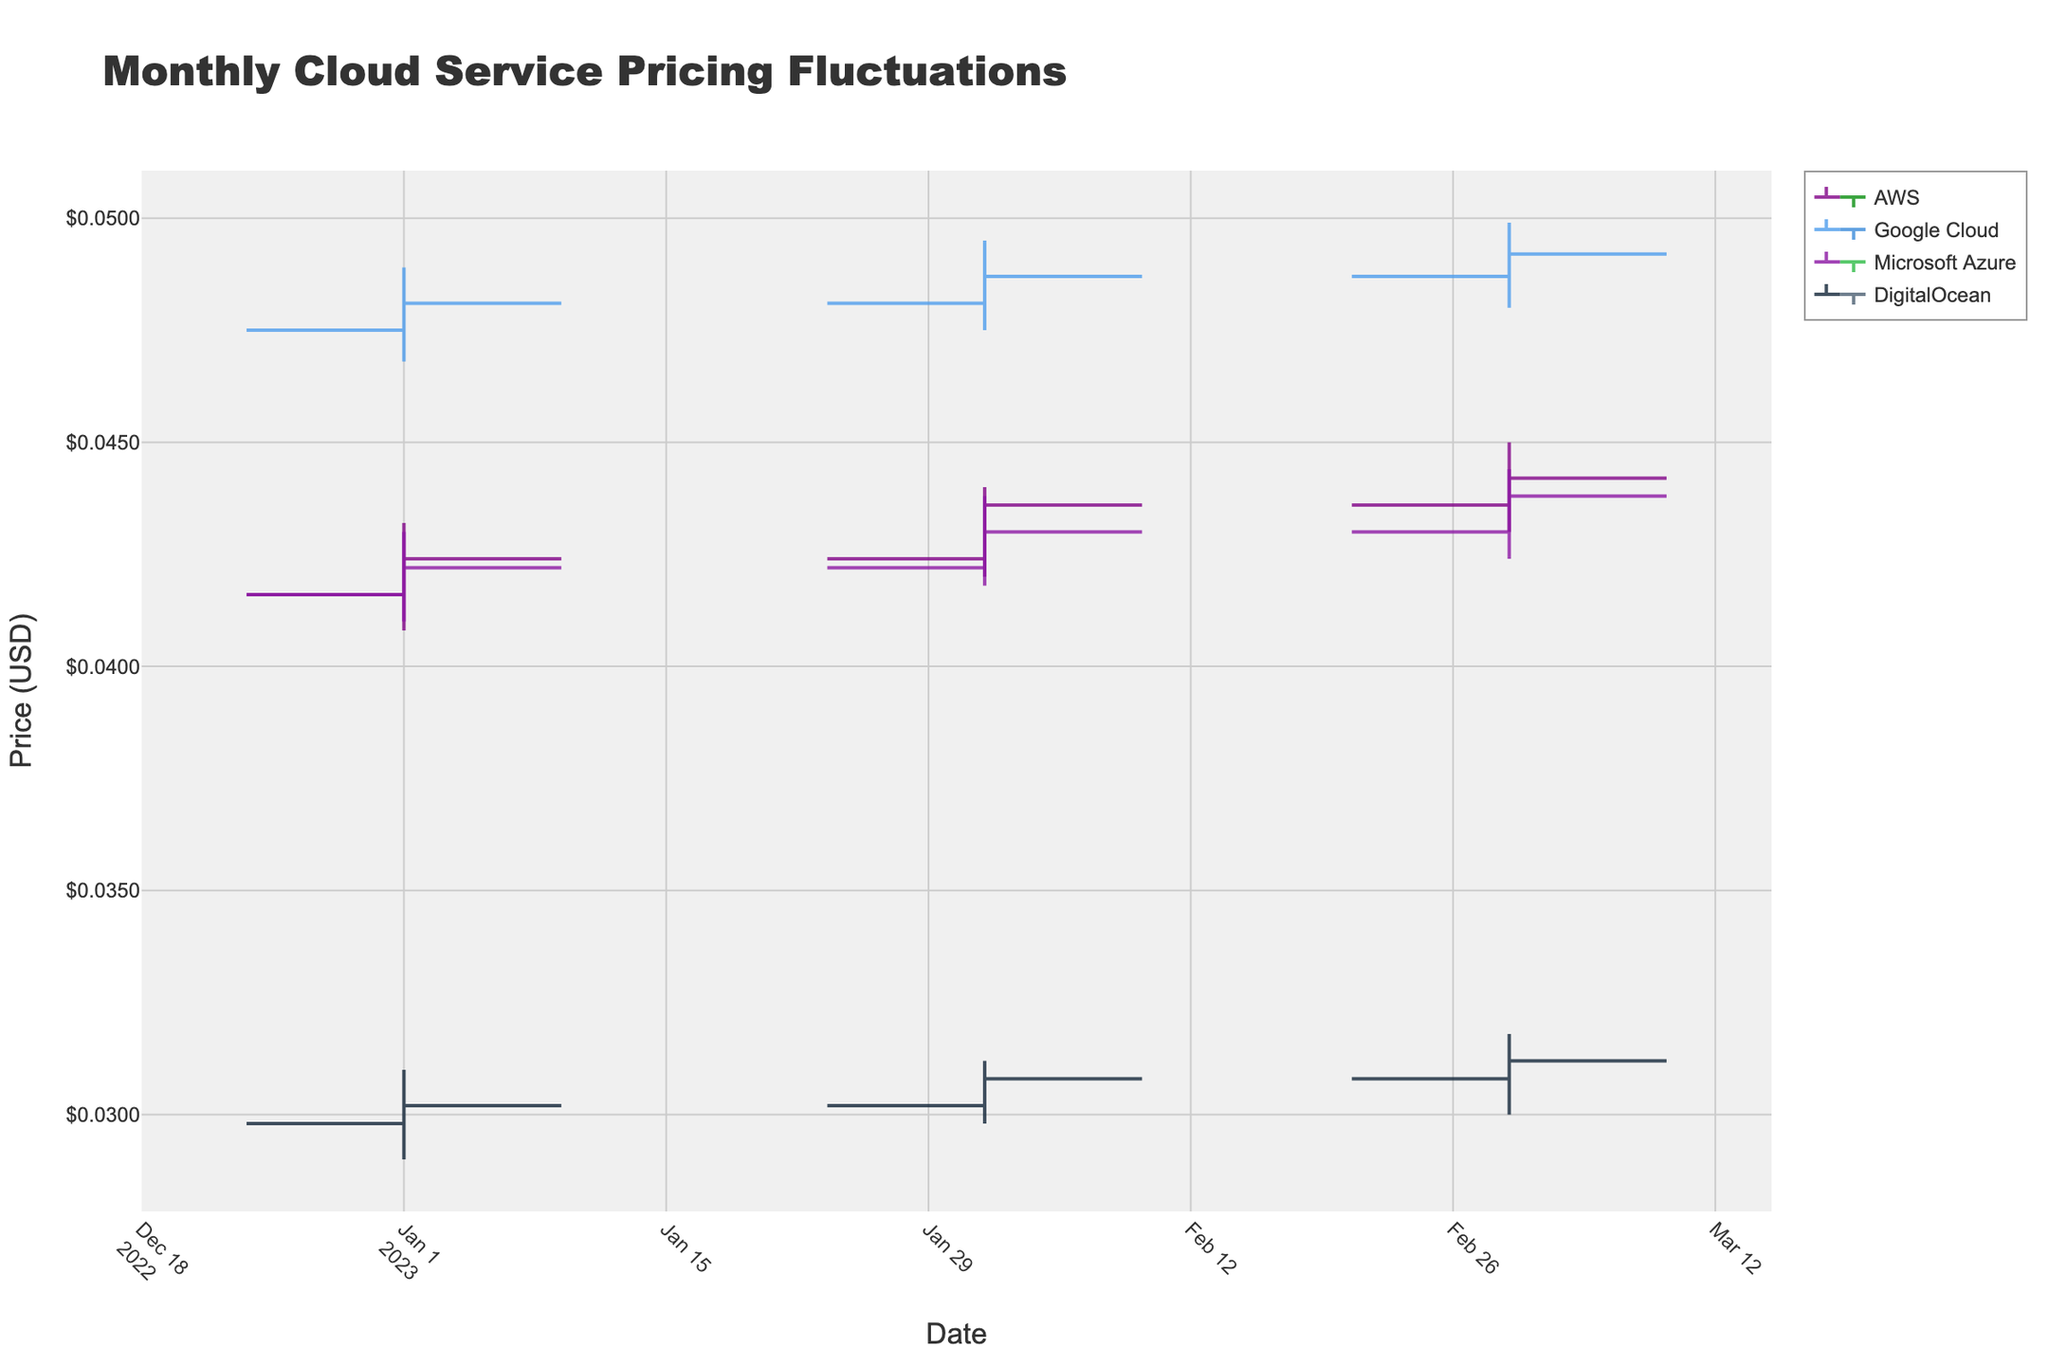What is the title of the chart? The title is usually displayed at the top of the chart to indicate what the chart is about. We can find this information directly by looking at the top portion of the figure.
Answer: Monthly Cloud Service Pricing Fluctuations How many major cloud service providers are compared in the chart? Count the number of unique providers, each represented by a different color in the OHLC plot's legend.
Answer: 4 Which provider had the highest closing price in March 2023? To determine this, we need to look at the closing prices for each provider in March 2023 and compare them. Based on the OHLC bars, Google Cloud had the highest closing price of $0.0492 in March 2023.
Answer: Google Cloud Which provider exhibits the most frequent price fluctuations (most number of changes in high and low prices) over the three months? Look at the high and low points of each provider's OHLC bars to see which one has the most variations. By inspecting the OHLC bars for all months, AWS has visible frequent price changes.
Answer: AWS What is the average closing price of Google Cloud Compute Engine over the three observed months? Average is calculated by summing the closing prices for Google Cloud over January, February, and March and then dividing by three. The calculation is (0.0481 + 0.0487 + 0.0492) / 3 = 0.04867.
Answer: 0.04867 Which service type and tier showed the smallest price range in February 2023? Identify the service type and tier by comparing the range (difference between high and low prices) for each provider in February 2023. Calculate the ranges: AWS: 0.0440-0.0420, Google: 0.0495-0.0475, Azure: 0.0438-0.0418, DigitalOcean: 0.0312-0.0298. DigitalOcean has the smallest range of 0.0014.
Answer: DigitalOcean Droplets Standard Did any provider's closing price decrease every month from January to March? Examine the trends of the closing prices month-over-month for each provider. None of the providers exhibit a consistent decrease in closing prices over the three months.
Answer: No What is the highest high price recorded for AWS EC2 t3.medium throughout the three months? To find this, look at the maximum high price recorded in the OHLC bars for AWS across January, February, and March. The highest high price for AWS was $0.0450 in March.
Answer: $0.0450 How much did the closing price for Microsoft Azure Virtual Machines B2s increase from January to March? Subtract the closing price in January from the closing price in March: 0.0438 - 0.0422 = 0.0016.
Answer: 0.0016 